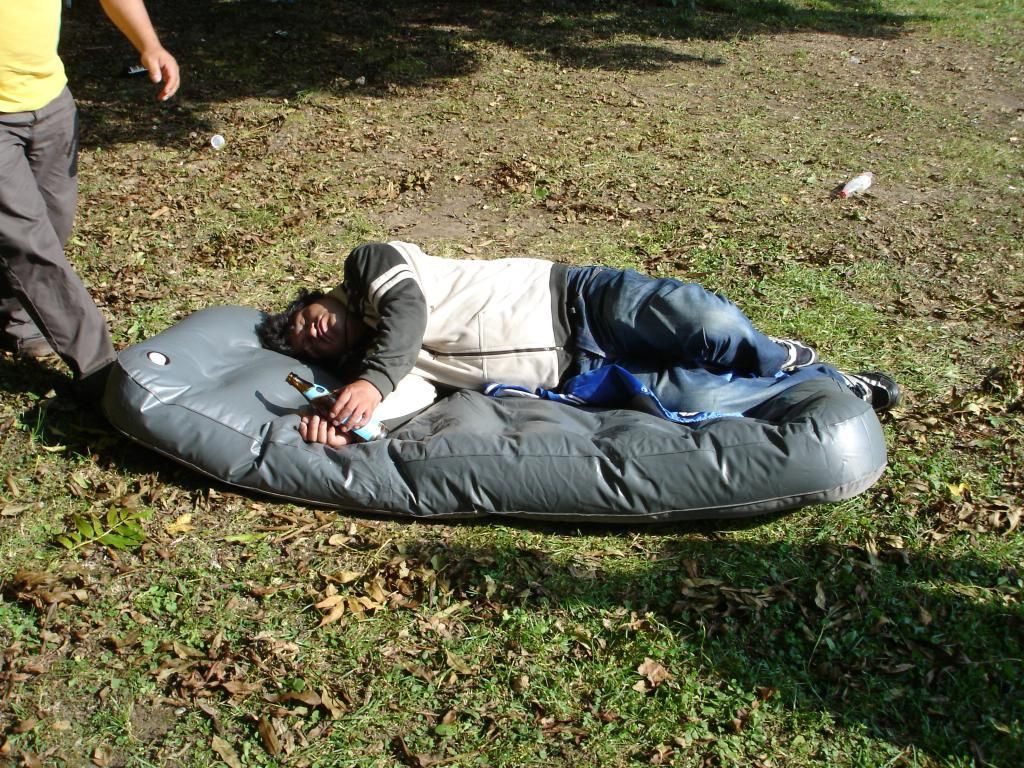What is the main subject in the center of the image? There is a person sleeping on an air bed in the center of the image. What type of surface is visible at the bottom of the image? There is grass at the bottom of the image. Can you describe the person on the left side of the image? There is a person on the left side of the image, but no specific details are provided about them. What type of linen is draped over the boat in the image? There is no boat present in the image, so there is no linen draped over it. 